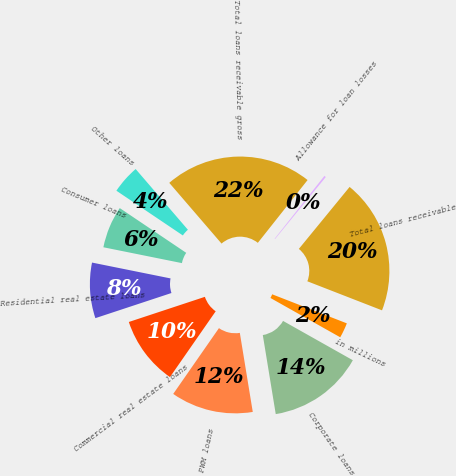Convert chart to OTSL. <chart><loc_0><loc_0><loc_500><loc_500><pie_chart><fcel>in millions<fcel>Corporate loans<fcel>PWM loans<fcel>Commercial real estate loans<fcel>Residential real estate loans<fcel>Consumer loans<fcel>Other loans<fcel>Total loans receivable gross<fcel>Allowance for loan losses<fcel>Total loans receivable<nl><fcel>2.26%<fcel>14.25%<fcel>12.25%<fcel>10.25%<fcel>8.25%<fcel>6.26%<fcel>4.26%<fcel>21.97%<fcel>0.26%<fcel>19.98%<nl></chart> 